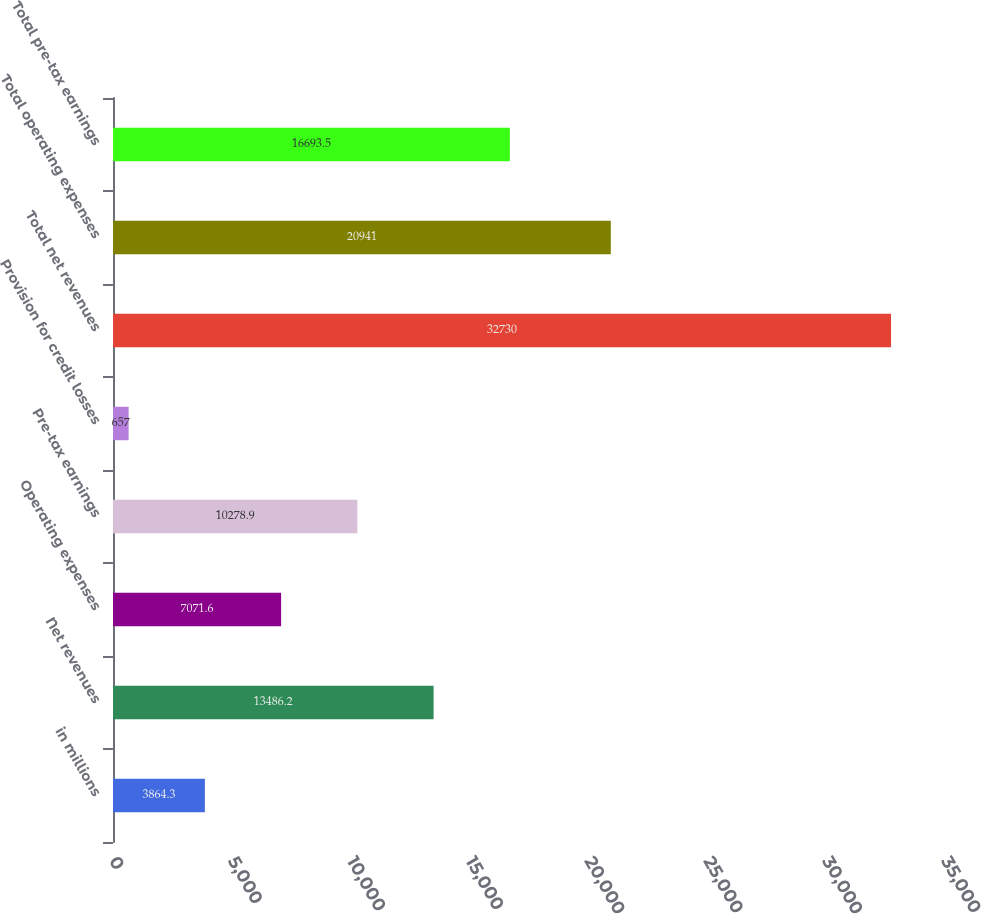Convert chart. <chart><loc_0><loc_0><loc_500><loc_500><bar_chart><fcel>in millions<fcel>Net revenues<fcel>Operating expenses<fcel>Pre-tax earnings<fcel>Provision for credit losses<fcel>Total net revenues<fcel>Total operating expenses<fcel>Total pre-tax earnings<nl><fcel>3864.3<fcel>13486.2<fcel>7071.6<fcel>10278.9<fcel>657<fcel>32730<fcel>20941<fcel>16693.5<nl></chart> 